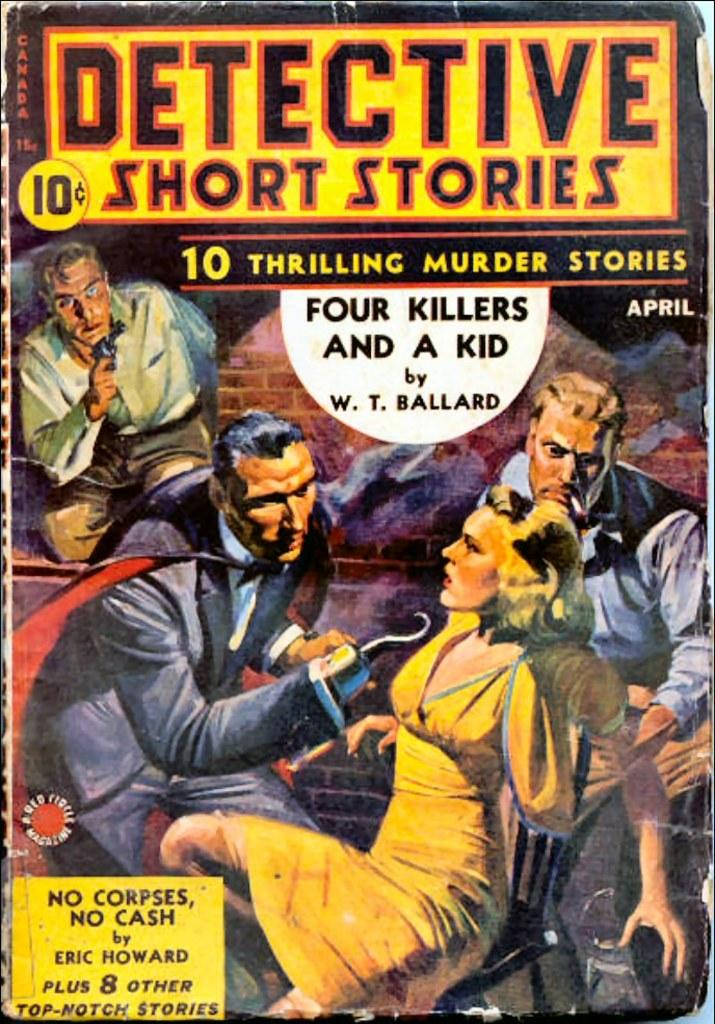<image>
Summarize the visual content of the image. Book cover showing a man with a hook hand named "Detective short stories". 